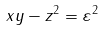<formula> <loc_0><loc_0><loc_500><loc_500>x y - z ^ { 2 } = \varepsilon ^ { 2 }</formula> 